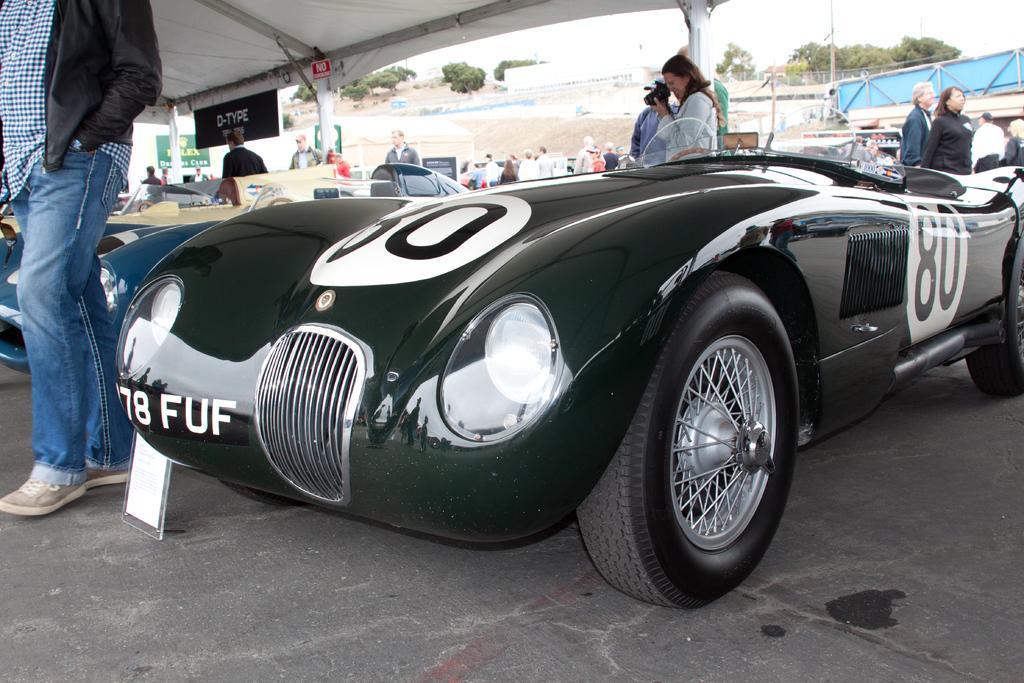In one or two sentences, can you explain what this image depicts? In this image there are vehicles parked, around the vehicles there are a few people standing and walking. At the top of the image there is a tent and few banners are hanging. In the background there is a fence, buildings, trees and the sky. 